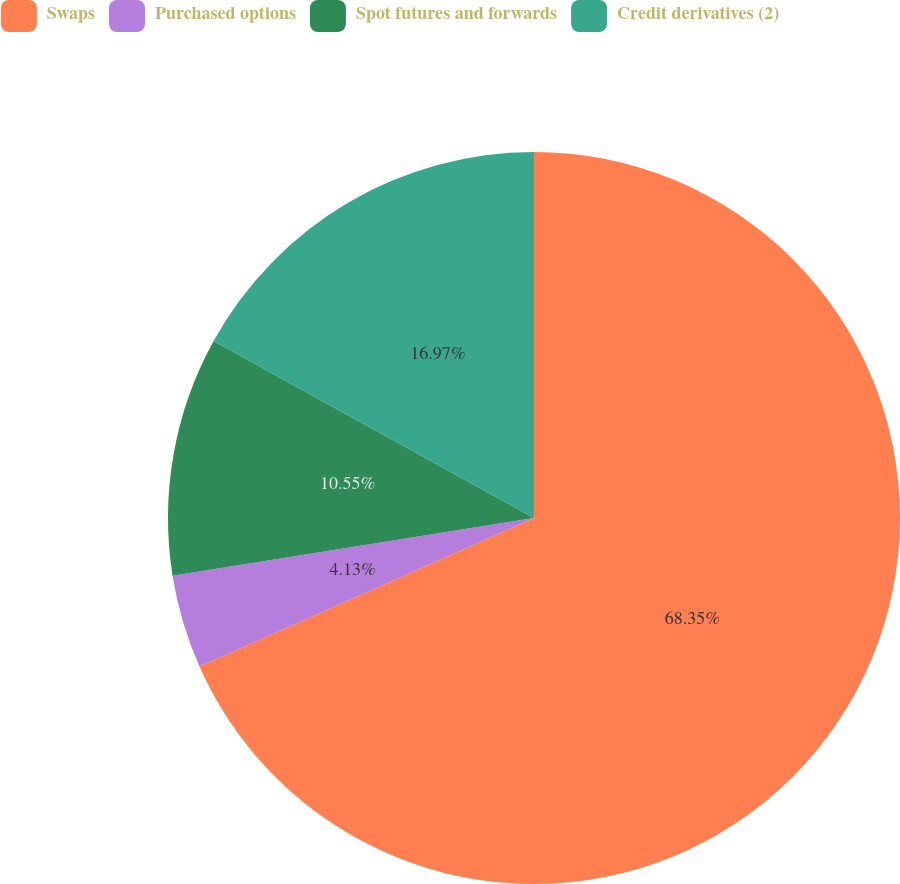Convert chart. <chart><loc_0><loc_0><loc_500><loc_500><pie_chart><fcel>Swaps<fcel>Purchased options<fcel>Spot futures and forwards<fcel>Credit derivatives (2)<nl><fcel>68.35%<fcel>4.13%<fcel>10.55%<fcel>16.97%<nl></chart> 